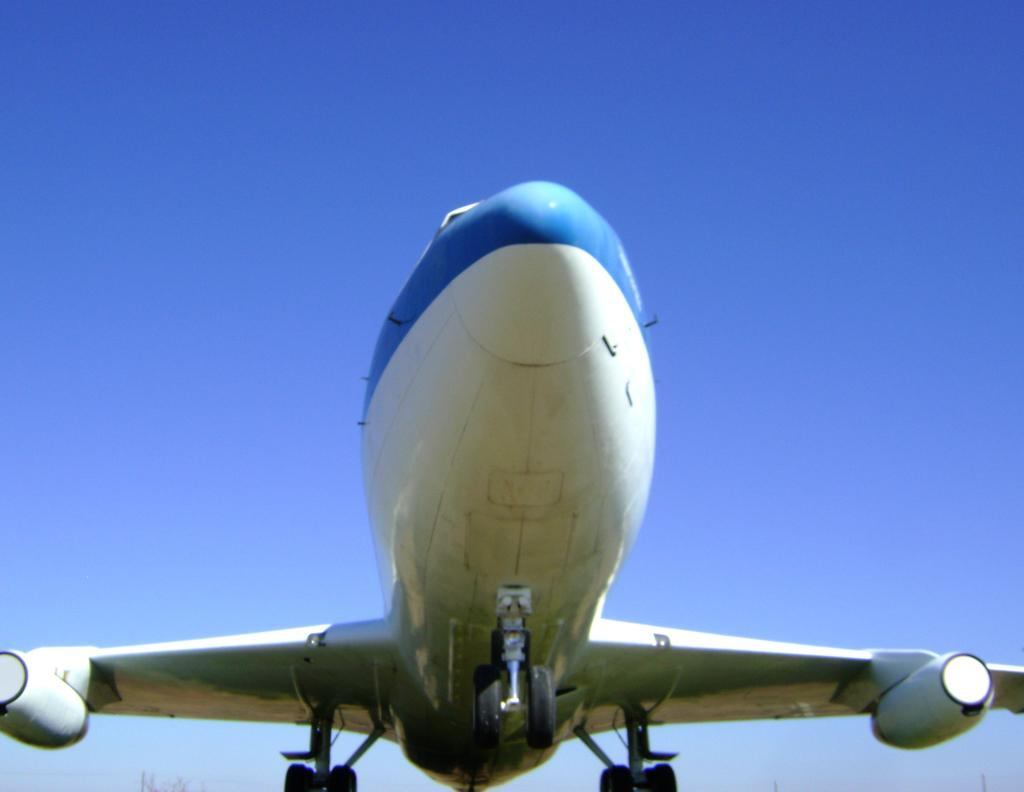What is the main subject of the picture? The main subject of the picture is an airplane. Where is the airplane located in the picture? The airplane is in the middle of the picture. What can be seen in the background of the picture? The sky is visible in the background of the picture. How many dogs are visible in the picture? There are no dogs present in the picture; it features an airplane and the sky. What type of face can be seen on the airplane in the picture? There is no face present on the airplane in the picture. 